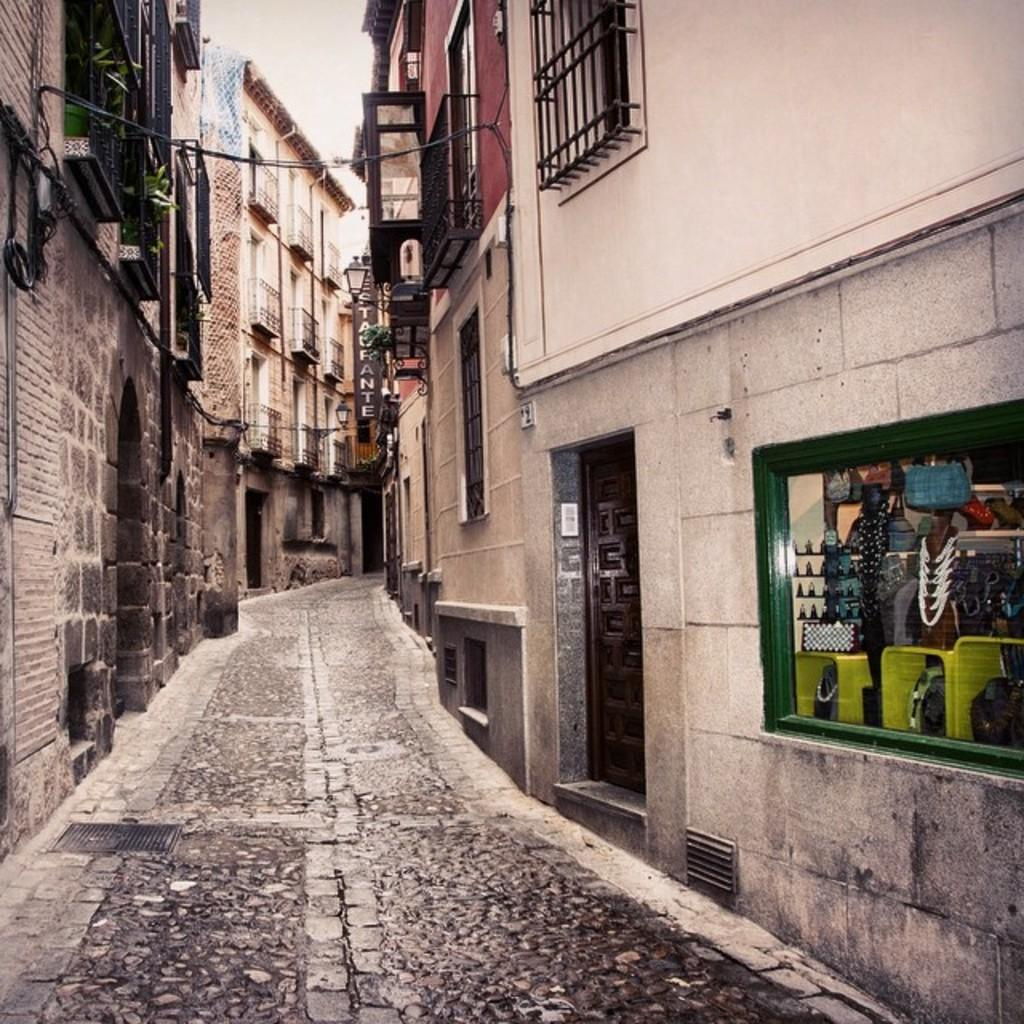What type of structures can be seen in the image? There are buildings in the image. What can be found on the left side of the image? There are plants on the left side of the image. Can you describe a specific feature in the image? There is a light in the image. What else can be seen in the image? There is a wire and a board in the image. What is located on the right side of the image? There are grilles and a door on the right side of the image. Is there a wound visible on the door in the image? There is no mention of a wound in the image, and the door appears to be undamaged. Can you see a beast lurking behind the plants in the image? There is no beast present in the image; only plants, buildings, and other objects are visible. 